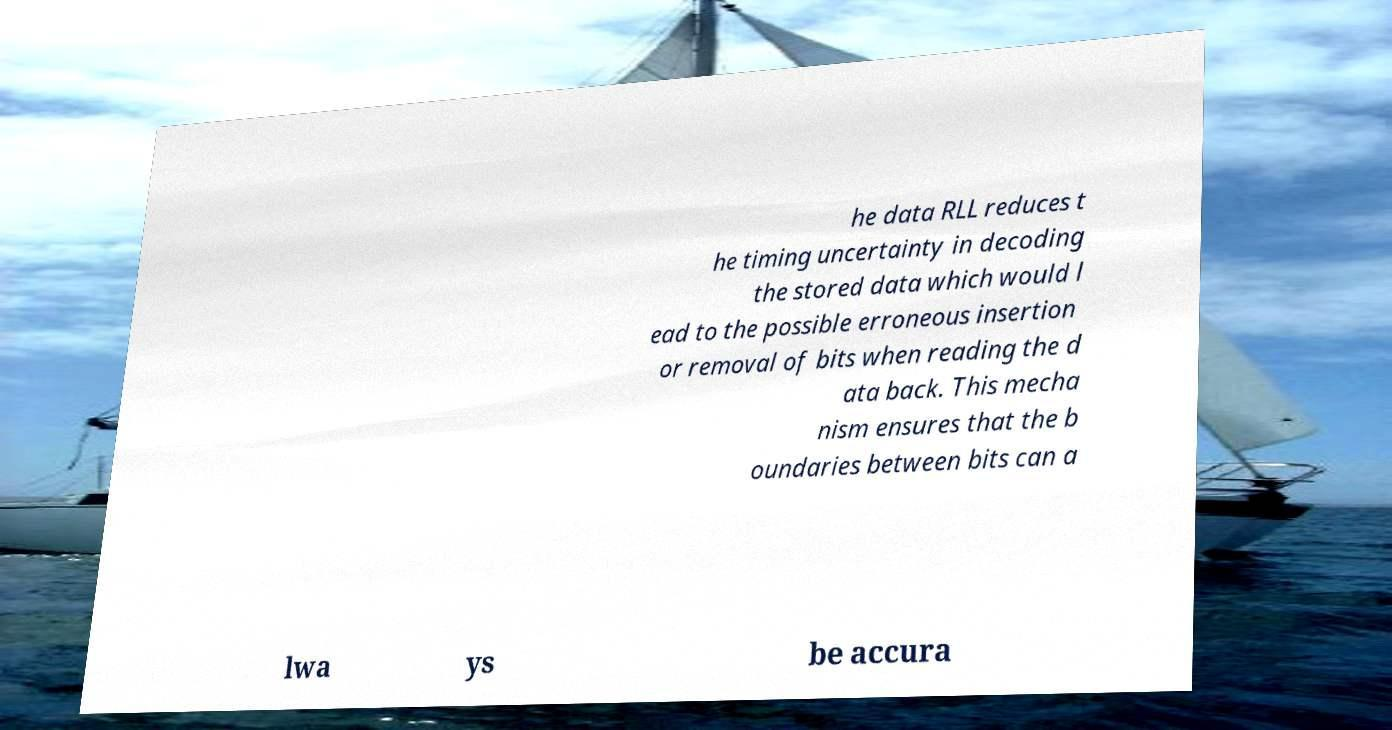Can you read and provide the text displayed in the image?This photo seems to have some interesting text. Can you extract and type it out for me? he data RLL reduces t he timing uncertainty in decoding the stored data which would l ead to the possible erroneous insertion or removal of bits when reading the d ata back. This mecha nism ensures that the b oundaries between bits can a lwa ys be accura 